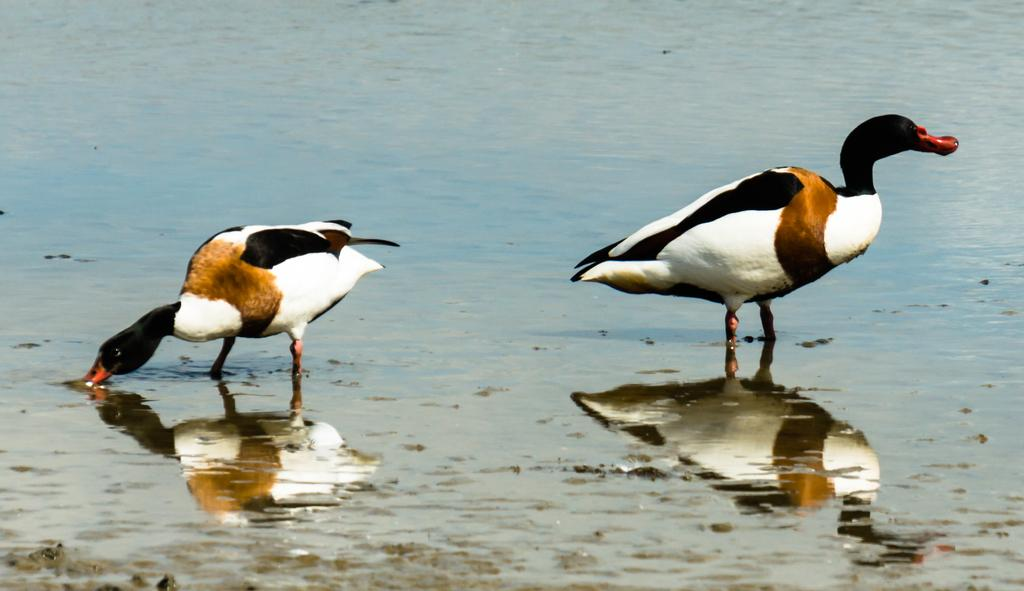How many birds are present in the image? There are two birds in the image. What are the birds doing in the image? The birds are standing in water. What type of plough is being used by the birds in the image? There is no plough present in the image; it features two birds standing in water. What type of stew is being prepared by the birds in the image? There is no stew or cooking activity present in the image; it features two birds standing in water. 